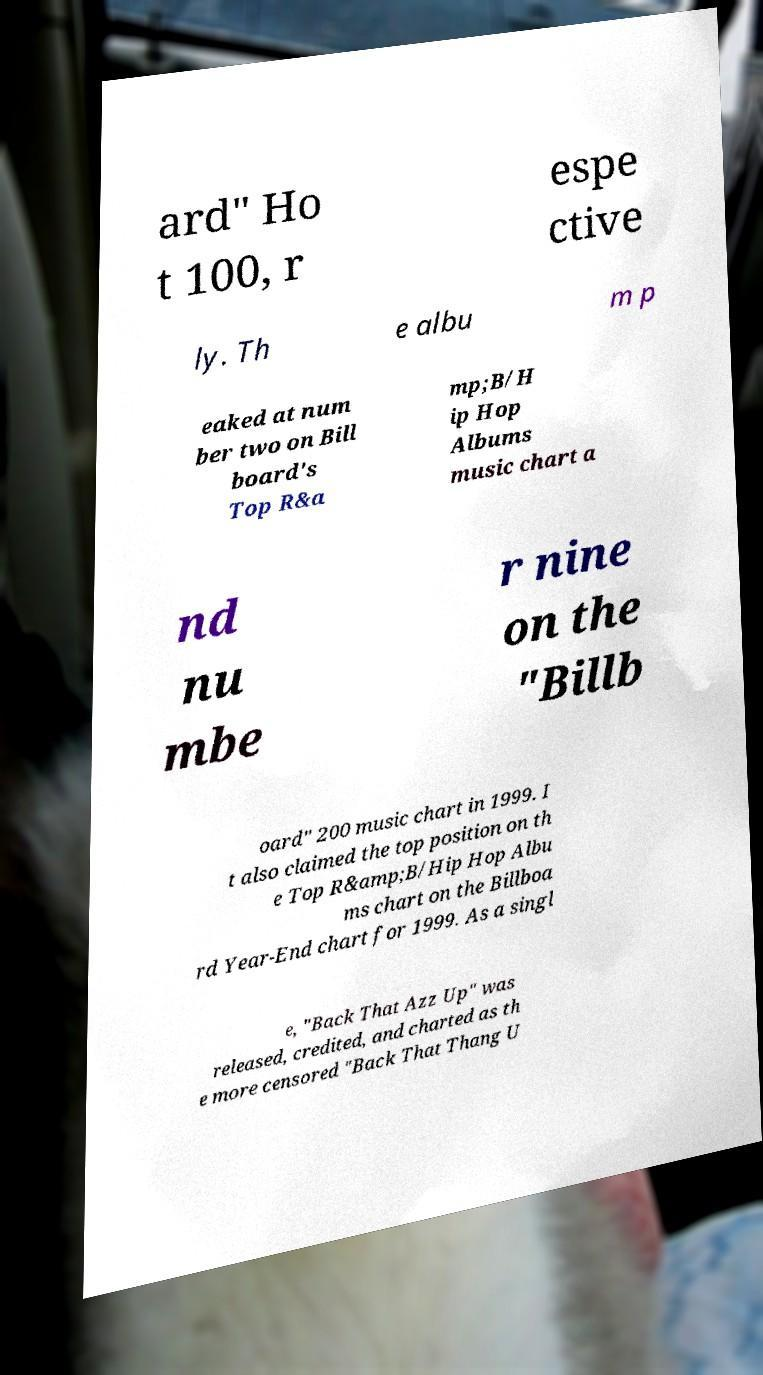For documentation purposes, I need the text within this image transcribed. Could you provide that? ard" Ho t 100, r espe ctive ly. Th e albu m p eaked at num ber two on Bill board's Top R&a mp;B/H ip Hop Albums music chart a nd nu mbe r nine on the "Billb oard" 200 music chart in 1999. I t also claimed the top position on th e Top R&amp;B/Hip Hop Albu ms chart on the Billboa rd Year-End chart for 1999. As a singl e, "Back That Azz Up" was released, credited, and charted as th e more censored "Back That Thang U 